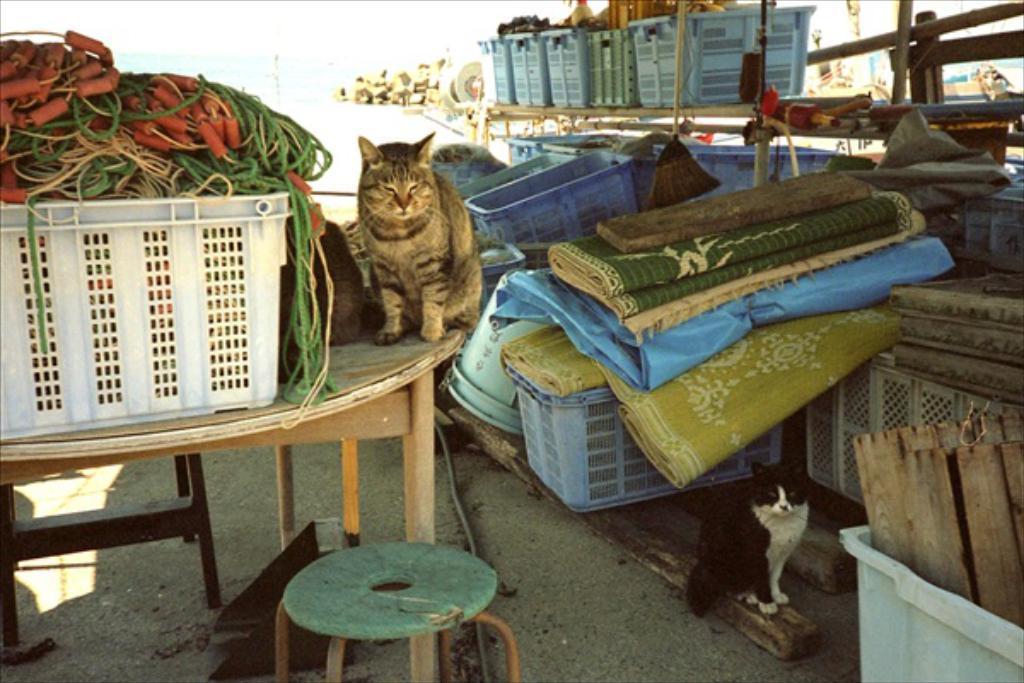Could you give a brief overview of what you see in this image? There is a cat on the table and there are some other objects beside it and there is also a black cat in the right corner and there are some other objects in the background. 